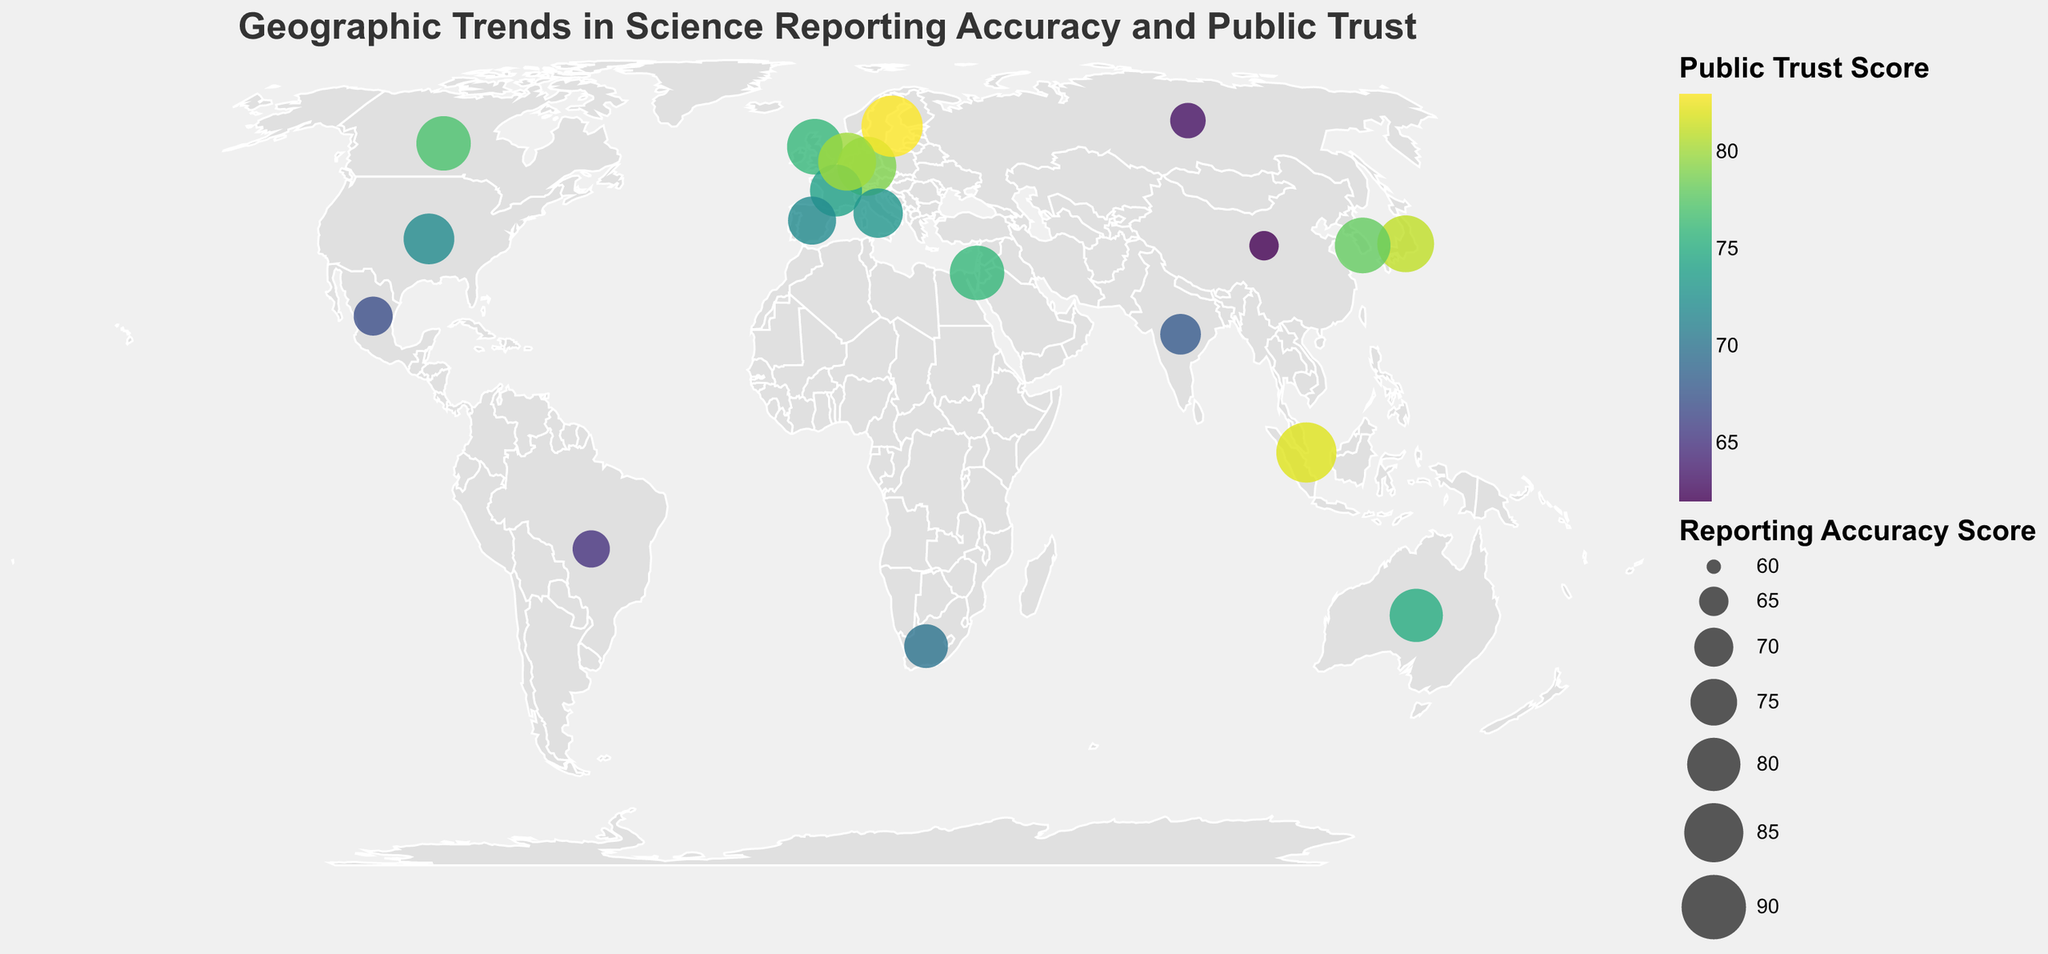How many countries are represented in the figure? Count the number of data points (countries) plotted on the map.
Answer: 20 Which country has the highest Reporting Accuracy Score? Look for the largest circle size on the map and check the tooltip or legend to identify the country.
Answer: Sweden Which country has the lowest level of public trust in scientific news? Find the country with the color indicating the lowest Public Trust Score by using the color legend.
Answer: China What is the average Public Trust Score for the countries represented? Add all the Public Trust Scores and divide by the number of countries (20). (72 + 76 + 79 + 81 + 75 + 77 + 74 + 83 + 68 + 65 + 62 + 70 + 63 + 73 + 80 + 78 + 67 + 72 + 76 + 82) / 20 = 74.5
Answer: 74.5 Which region shows higher accuracy and public trust, Western Europe or East Asia? Check the Reporting Accuracy Scores and Public Trust Scores for countries in Western Europe (e.g., United Kingdom, Germany, France, Netherlands) and East Asia (e.g., Japan, China, South Korea, Singapore) and compare their averages.
Answer: Western Europe What is the difference in Reporting Accuracy Score between the country with the highest score and the country with the lowest score? Identify the highest and lowest scores from the data (highest: Sweden 87, lowest: China 65) and subtract the lowest from the highest (87 - 65).
Answer: 22 How does the Public Trust Score for Brazil compare to that of South Africa? Find the Public Trust Scores for Brazil (65) and South Africa (70) from the map and compare the two.
Answer: Brazil has a lower Public Trust Score than South Africa Among the countries with a Reporting Accuracy Score above 80, which one has the lowest Public Trust Score? Filter the countries with Reporting Accuracy Score > 80 (United Kingdom, Germany, Japan, Australia, Canada, Sweden, Netherlands, South Korea, Israel, Singapore) and then identify the lowest Public Trust Score among them.
Answer: Australia Which countries have both Reporting Accuracy Scores and Public Trust Scores above 80? Find all countries where both scores are higher than 80 (Germany, Japan, Sweden, Netherlands, Singapore).
Answer: Germany, Japan, Sweden, Netherlands, Singapore What is the range of the Reporting Accuracy Scores displayed on the map? Identify the highest (Sweden 87) and lowest (China 65) Reporting Accuracy Scores and subtract the lowest from the highest (87 - 65).
Answer: 22 